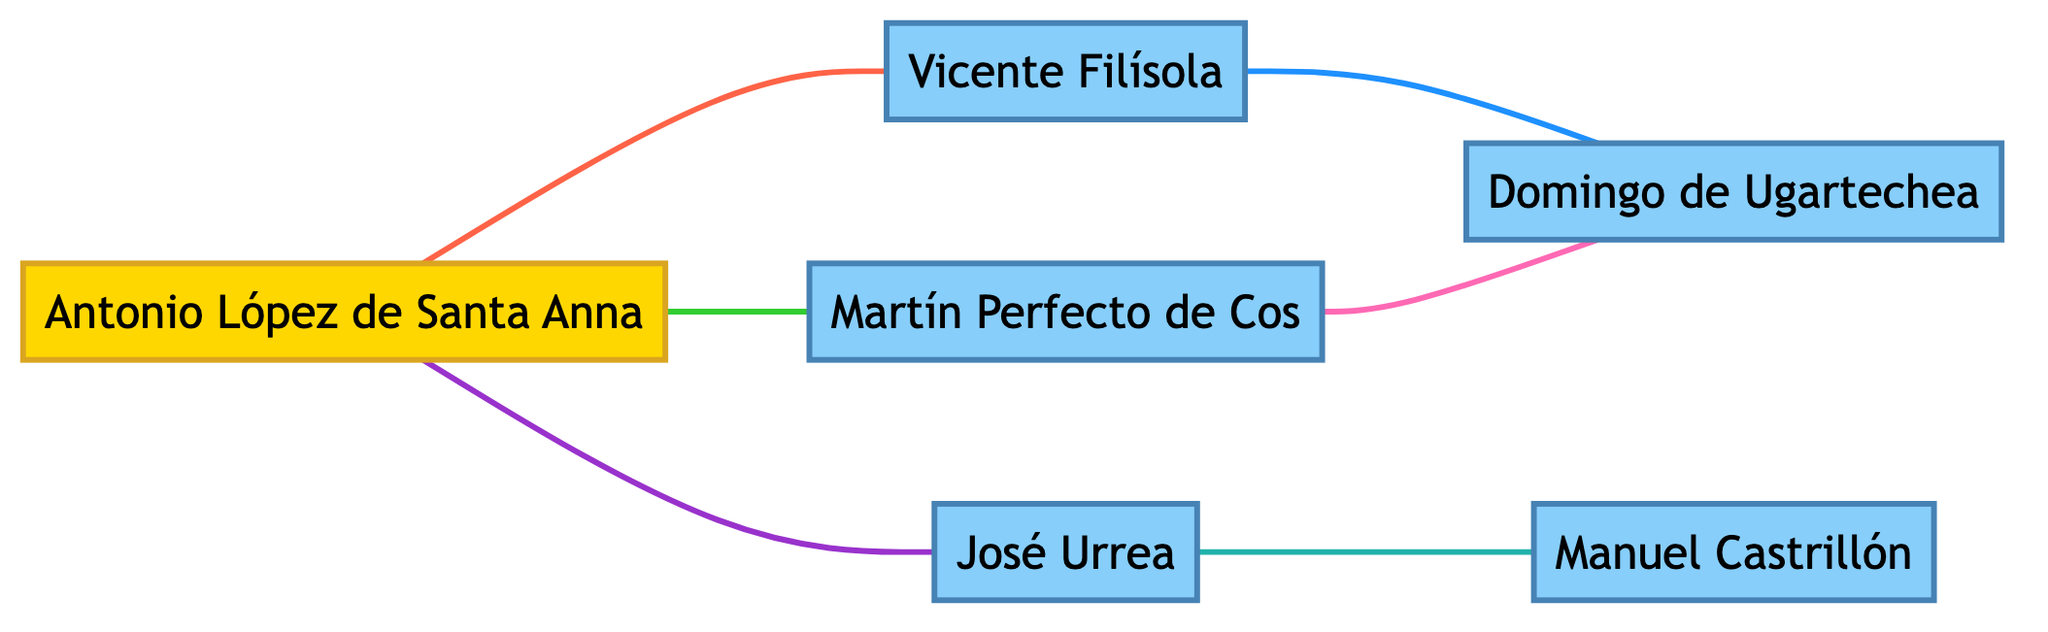What are the total number of nodes in the diagram? The diagram has a total of 6 nodes representing individuals involved in the correspondence and communication during the Texas Revolution.
Answer: 6 Who communicates with Vicente Filísola? Antonio López de Santa Anna is the node directly linked to Vicente Filísola by the "Communicates" edge.
Answer: Antonio López de Santa Anna What type of relationship is there between José Urrea and Manuel Castrillón? The edge connecting José Urrea and Manuel Castrillón is labeled "Military Plans," indicating a specific type of relationship focused on military strategy.
Answer: Military Plans How many edges are there in the diagram? By counting the connections, there are 6 edges in total that represent various forms of communication and relationships between the nodes.
Answer: 6 Which two individuals are involved in "Coordination"? The connection labeled "Coordination" exists between Martín Perfecto de Cos and Domingo de Ugartechea, indicating a specific collaborative effort.
Answer: Martín Perfecto de Cos and Domingo de Ugartechea Who has the most direct connections? Antonio López de Santa Anna has the most direct connections, as he is linked to three other nodes: Vicente Filísola, Martín Perfecto de Cos, and José Urrea.
Answer: Antonio López de Santa Anna What is the nature of the edge between Vicente Filísola and Domingo de Ugartechea? The edge between Vicente Filísola and Domingo de Ugartechea is labeled "Strategic Updates," indicating a focused exchange of information regarding strategy.
Answer: Strategic Updates Which leader is connected to the most nodes? Antonio López de Santa Anna is connected to three nodes, more than any other leader in the diagram.
Answer: Antonio López de Santa Anna What is the total number of relationships connecting Martín Perfecto de Cos? Martín Perfecto de Cos is connected to two other individuals, which totals to 2 relationships in this context.
Answer: 2 